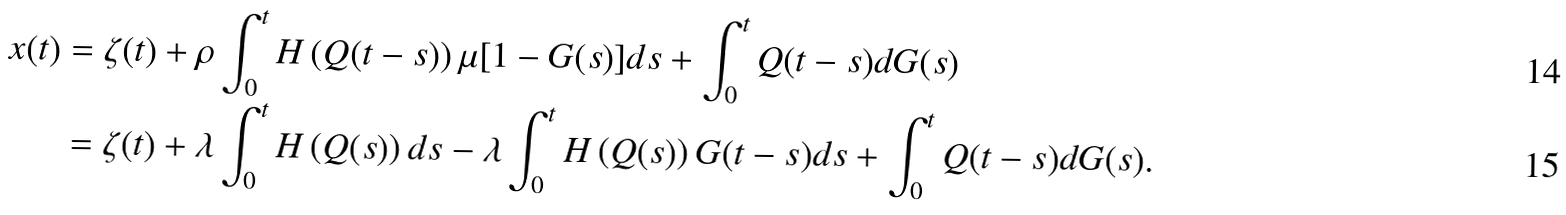<formula> <loc_0><loc_0><loc_500><loc_500>x ( t ) & = \zeta ( t ) + \rho \int _ { 0 } ^ { t } H \left ( Q ( t - s ) \right ) \mu [ 1 - G ( s ) ] d s + \int _ { 0 } ^ { t } Q ( t - s ) d G ( s ) \\ & = \zeta ( t ) + \lambda \int _ { 0 } ^ { t } H \left ( Q ( s ) \right ) d s - \lambda \int _ { 0 } ^ { t } H \left ( Q ( s ) \right ) G ( t - s ) d s + \int _ { 0 } ^ { t } Q ( t - s ) d G ( s ) .</formula> 